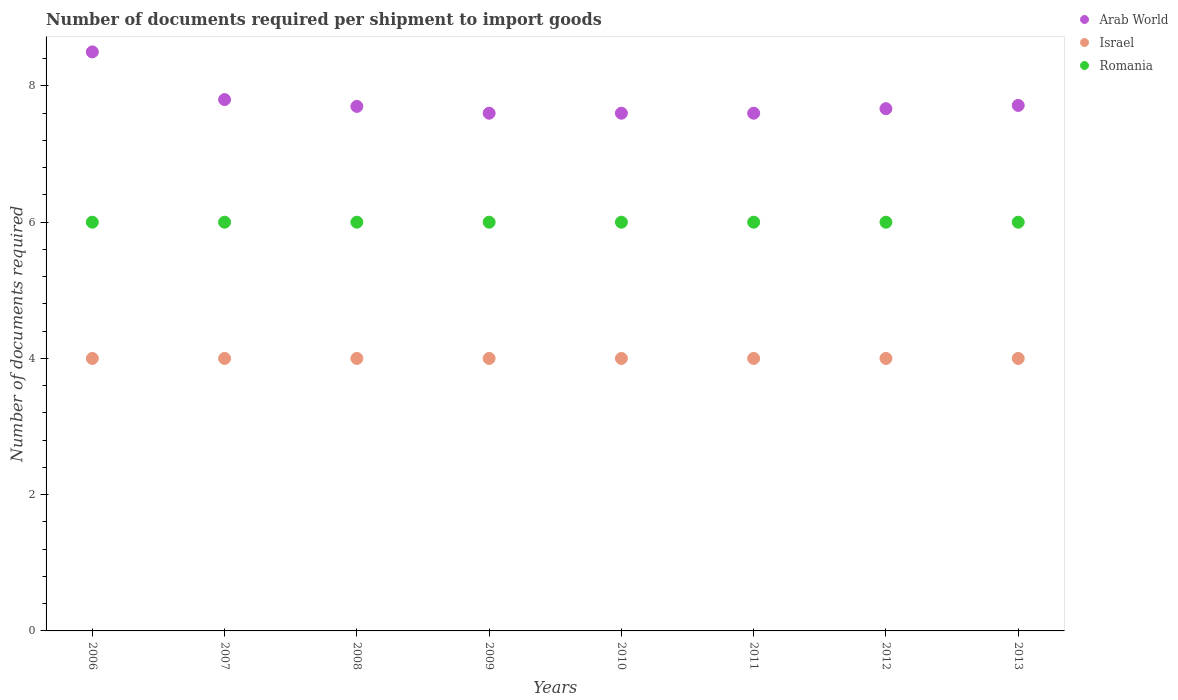Is the number of dotlines equal to the number of legend labels?
Offer a very short reply. Yes. What is the number of documents required per shipment to import goods in Romania in 2006?
Make the answer very short. 6. Across all years, what is the minimum number of documents required per shipment to import goods in Israel?
Your response must be concise. 4. In which year was the number of documents required per shipment to import goods in Israel maximum?
Offer a very short reply. 2006. In which year was the number of documents required per shipment to import goods in Arab World minimum?
Make the answer very short. 2009. What is the total number of documents required per shipment to import goods in Israel in the graph?
Provide a succinct answer. 32. What is the difference between the number of documents required per shipment to import goods in Romania in 2010 and the number of documents required per shipment to import goods in Israel in 2008?
Offer a terse response. 2. What is the average number of documents required per shipment to import goods in Romania per year?
Make the answer very short. 6. In the year 2006, what is the difference between the number of documents required per shipment to import goods in Israel and number of documents required per shipment to import goods in Arab World?
Offer a terse response. -4.5. In how many years, is the number of documents required per shipment to import goods in Israel greater than 5.2?
Your answer should be very brief. 0. What is the ratio of the number of documents required per shipment to import goods in Arab World in 2007 to that in 2011?
Your answer should be very brief. 1.03. What is the difference between the highest and the second highest number of documents required per shipment to import goods in Romania?
Give a very brief answer. 0. In how many years, is the number of documents required per shipment to import goods in Israel greater than the average number of documents required per shipment to import goods in Israel taken over all years?
Provide a short and direct response. 0. Is the sum of the number of documents required per shipment to import goods in Romania in 2009 and 2011 greater than the maximum number of documents required per shipment to import goods in Arab World across all years?
Make the answer very short. Yes. Does the number of documents required per shipment to import goods in Israel monotonically increase over the years?
Your answer should be very brief. No. How many years are there in the graph?
Keep it short and to the point. 8. Does the graph contain any zero values?
Offer a very short reply. No. Does the graph contain grids?
Your answer should be compact. No. Where does the legend appear in the graph?
Offer a terse response. Top right. How many legend labels are there?
Offer a terse response. 3. What is the title of the graph?
Your response must be concise. Number of documents required per shipment to import goods. What is the label or title of the Y-axis?
Make the answer very short. Number of documents required. What is the Number of documents required of Arab World in 2006?
Make the answer very short. 8.5. What is the Number of documents required in Romania in 2006?
Provide a succinct answer. 6. What is the Number of documents required in Arab World in 2007?
Provide a succinct answer. 7.8. What is the Number of documents required of Israel in 2007?
Ensure brevity in your answer.  4. What is the Number of documents required of Arab World in 2008?
Offer a very short reply. 7.7. What is the Number of documents required of Romania in 2008?
Provide a succinct answer. 6. What is the Number of documents required of Israel in 2009?
Ensure brevity in your answer.  4. What is the Number of documents required in Romania in 2009?
Your response must be concise. 6. What is the Number of documents required of Israel in 2011?
Offer a terse response. 4. What is the Number of documents required of Arab World in 2012?
Offer a terse response. 7.67. What is the Number of documents required of Israel in 2012?
Keep it short and to the point. 4. What is the Number of documents required of Arab World in 2013?
Give a very brief answer. 7.71. Across all years, what is the maximum Number of documents required in Arab World?
Your response must be concise. 8.5. Across all years, what is the minimum Number of documents required in Israel?
Provide a succinct answer. 4. Across all years, what is the minimum Number of documents required in Romania?
Offer a very short reply. 6. What is the total Number of documents required of Arab World in the graph?
Offer a terse response. 62.18. What is the total Number of documents required of Romania in the graph?
Provide a short and direct response. 48. What is the difference between the Number of documents required of Romania in 2006 and that in 2007?
Your answer should be compact. 0. What is the difference between the Number of documents required in Romania in 2006 and that in 2008?
Your answer should be compact. 0. What is the difference between the Number of documents required of Israel in 2006 and that in 2009?
Your response must be concise. 0. What is the difference between the Number of documents required in Romania in 2006 and that in 2009?
Your answer should be compact. 0. What is the difference between the Number of documents required in Arab World in 2006 and that in 2010?
Give a very brief answer. 0.9. What is the difference between the Number of documents required in Israel in 2006 and that in 2010?
Provide a short and direct response. 0. What is the difference between the Number of documents required in Israel in 2006 and that in 2011?
Provide a succinct answer. 0. What is the difference between the Number of documents required in Arab World in 2006 and that in 2012?
Make the answer very short. 0.83. What is the difference between the Number of documents required in Romania in 2006 and that in 2012?
Give a very brief answer. 0. What is the difference between the Number of documents required of Arab World in 2006 and that in 2013?
Your answer should be very brief. 0.79. What is the difference between the Number of documents required in Romania in 2006 and that in 2013?
Make the answer very short. 0. What is the difference between the Number of documents required in Arab World in 2007 and that in 2008?
Your answer should be compact. 0.1. What is the difference between the Number of documents required in Israel in 2007 and that in 2009?
Ensure brevity in your answer.  0. What is the difference between the Number of documents required of Israel in 2007 and that in 2010?
Your response must be concise. 0. What is the difference between the Number of documents required in Arab World in 2007 and that in 2011?
Your answer should be compact. 0.2. What is the difference between the Number of documents required of Israel in 2007 and that in 2011?
Offer a very short reply. 0. What is the difference between the Number of documents required in Arab World in 2007 and that in 2012?
Your answer should be very brief. 0.13. What is the difference between the Number of documents required of Romania in 2007 and that in 2012?
Offer a very short reply. 0. What is the difference between the Number of documents required in Arab World in 2007 and that in 2013?
Your response must be concise. 0.09. What is the difference between the Number of documents required of Romania in 2007 and that in 2013?
Offer a very short reply. 0. What is the difference between the Number of documents required of Arab World in 2008 and that in 2009?
Your answer should be compact. 0.1. What is the difference between the Number of documents required of Israel in 2008 and that in 2010?
Keep it short and to the point. 0. What is the difference between the Number of documents required of Romania in 2008 and that in 2010?
Your answer should be compact. 0. What is the difference between the Number of documents required of Israel in 2008 and that in 2011?
Provide a short and direct response. 0. What is the difference between the Number of documents required in Romania in 2008 and that in 2011?
Ensure brevity in your answer.  0. What is the difference between the Number of documents required of Arab World in 2008 and that in 2012?
Offer a terse response. 0.03. What is the difference between the Number of documents required in Israel in 2008 and that in 2012?
Offer a terse response. 0. What is the difference between the Number of documents required of Romania in 2008 and that in 2012?
Offer a very short reply. 0. What is the difference between the Number of documents required of Arab World in 2008 and that in 2013?
Keep it short and to the point. -0.01. What is the difference between the Number of documents required of Israel in 2008 and that in 2013?
Ensure brevity in your answer.  0. What is the difference between the Number of documents required of Arab World in 2009 and that in 2011?
Your response must be concise. 0. What is the difference between the Number of documents required in Romania in 2009 and that in 2011?
Make the answer very short. 0. What is the difference between the Number of documents required in Arab World in 2009 and that in 2012?
Your response must be concise. -0.07. What is the difference between the Number of documents required of Romania in 2009 and that in 2012?
Offer a terse response. 0. What is the difference between the Number of documents required in Arab World in 2009 and that in 2013?
Give a very brief answer. -0.11. What is the difference between the Number of documents required of Romania in 2009 and that in 2013?
Give a very brief answer. 0. What is the difference between the Number of documents required in Romania in 2010 and that in 2011?
Ensure brevity in your answer.  0. What is the difference between the Number of documents required in Arab World in 2010 and that in 2012?
Offer a very short reply. -0.07. What is the difference between the Number of documents required of Arab World in 2010 and that in 2013?
Provide a succinct answer. -0.11. What is the difference between the Number of documents required in Israel in 2010 and that in 2013?
Keep it short and to the point. 0. What is the difference between the Number of documents required in Romania in 2010 and that in 2013?
Ensure brevity in your answer.  0. What is the difference between the Number of documents required of Arab World in 2011 and that in 2012?
Ensure brevity in your answer.  -0.07. What is the difference between the Number of documents required in Arab World in 2011 and that in 2013?
Keep it short and to the point. -0.11. What is the difference between the Number of documents required in Romania in 2011 and that in 2013?
Your answer should be very brief. 0. What is the difference between the Number of documents required in Arab World in 2012 and that in 2013?
Give a very brief answer. -0.05. What is the difference between the Number of documents required in Romania in 2012 and that in 2013?
Offer a terse response. 0. What is the difference between the Number of documents required in Arab World in 2006 and the Number of documents required in Israel in 2007?
Your response must be concise. 4.5. What is the difference between the Number of documents required of Arab World in 2006 and the Number of documents required of Romania in 2007?
Make the answer very short. 2.5. What is the difference between the Number of documents required of Arab World in 2006 and the Number of documents required of Israel in 2008?
Make the answer very short. 4.5. What is the difference between the Number of documents required of Arab World in 2006 and the Number of documents required of Israel in 2010?
Your answer should be very brief. 4.5. What is the difference between the Number of documents required of Arab World in 2006 and the Number of documents required of Romania in 2010?
Provide a short and direct response. 2.5. What is the difference between the Number of documents required of Arab World in 2006 and the Number of documents required of Israel in 2011?
Your response must be concise. 4.5. What is the difference between the Number of documents required in Israel in 2006 and the Number of documents required in Romania in 2011?
Your answer should be very brief. -2. What is the difference between the Number of documents required of Arab World in 2006 and the Number of documents required of Israel in 2012?
Offer a terse response. 4.5. What is the difference between the Number of documents required in Arab World in 2006 and the Number of documents required in Romania in 2012?
Keep it short and to the point. 2.5. What is the difference between the Number of documents required in Arab World in 2006 and the Number of documents required in Romania in 2013?
Your answer should be very brief. 2.5. What is the difference between the Number of documents required of Israel in 2006 and the Number of documents required of Romania in 2013?
Offer a very short reply. -2. What is the difference between the Number of documents required of Arab World in 2007 and the Number of documents required of Israel in 2008?
Provide a short and direct response. 3.8. What is the difference between the Number of documents required in Israel in 2007 and the Number of documents required in Romania in 2009?
Ensure brevity in your answer.  -2. What is the difference between the Number of documents required of Arab World in 2007 and the Number of documents required of Romania in 2010?
Provide a succinct answer. 1.8. What is the difference between the Number of documents required of Israel in 2007 and the Number of documents required of Romania in 2010?
Your response must be concise. -2. What is the difference between the Number of documents required in Arab World in 2007 and the Number of documents required in Israel in 2011?
Offer a very short reply. 3.8. What is the difference between the Number of documents required of Israel in 2007 and the Number of documents required of Romania in 2011?
Offer a terse response. -2. What is the difference between the Number of documents required of Arab World in 2007 and the Number of documents required of Romania in 2012?
Provide a succinct answer. 1.8. What is the difference between the Number of documents required of Israel in 2007 and the Number of documents required of Romania in 2013?
Provide a succinct answer. -2. What is the difference between the Number of documents required of Arab World in 2008 and the Number of documents required of Israel in 2009?
Keep it short and to the point. 3.7. What is the difference between the Number of documents required in Arab World in 2008 and the Number of documents required in Romania in 2009?
Make the answer very short. 1.7. What is the difference between the Number of documents required in Arab World in 2008 and the Number of documents required in Romania in 2010?
Your answer should be very brief. 1.7. What is the difference between the Number of documents required in Arab World in 2008 and the Number of documents required in Israel in 2011?
Provide a short and direct response. 3.7. What is the difference between the Number of documents required of Israel in 2008 and the Number of documents required of Romania in 2011?
Give a very brief answer. -2. What is the difference between the Number of documents required of Arab World in 2008 and the Number of documents required of Israel in 2012?
Your response must be concise. 3.7. What is the difference between the Number of documents required in Arab World in 2008 and the Number of documents required in Romania in 2012?
Provide a short and direct response. 1.7. What is the difference between the Number of documents required of Israel in 2008 and the Number of documents required of Romania in 2012?
Offer a terse response. -2. What is the difference between the Number of documents required in Arab World in 2008 and the Number of documents required in Israel in 2013?
Give a very brief answer. 3.7. What is the difference between the Number of documents required in Arab World in 2009 and the Number of documents required in Israel in 2010?
Ensure brevity in your answer.  3.6. What is the difference between the Number of documents required in Arab World in 2009 and the Number of documents required in Romania in 2010?
Your response must be concise. 1.6. What is the difference between the Number of documents required of Israel in 2009 and the Number of documents required of Romania in 2010?
Keep it short and to the point. -2. What is the difference between the Number of documents required in Israel in 2009 and the Number of documents required in Romania in 2011?
Keep it short and to the point. -2. What is the difference between the Number of documents required in Arab World in 2009 and the Number of documents required in Israel in 2012?
Offer a very short reply. 3.6. What is the difference between the Number of documents required of Arab World in 2009 and the Number of documents required of Romania in 2012?
Provide a short and direct response. 1.6. What is the difference between the Number of documents required of Israel in 2009 and the Number of documents required of Romania in 2012?
Provide a short and direct response. -2. What is the difference between the Number of documents required in Arab World in 2010 and the Number of documents required in Israel in 2011?
Provide a succinct answer. 3.6. What is the difference between the Number of documents required of Israel in 2010 and the Number of documents required of Romania in 2011?
Keep it short and to the point. -2. What is the difference between the Number of documents required in Arab World in 2010 and the Number of documents required in Israel in 2012?
Make the answer very short. 3.6. What is the difference between the Number of documents required of Israel in 2010 and the Number of documents required of Romania in 2012?
Your answer should be compact. -2. What is the difference between the Number of documents required of Arab World in 2010 and the Number of documents required of Romania in 2013?
Make the answer very short. 1.6. What is the difference between the Number of documents required in Israel in 2010 and the Number of documents required in Romania in 2013?
Provide a succinct answer. -2. What is the difference between the Number of documents required of Arab World in 2011 and the Number of documents required of Israel in 2013?
Make the answer very short. 3.6. What is the difference between the Number of documents required of Israel in 2011 and the Number of documents required of Romania in 2013?
Offer a very short reply. -2. What is the difference between the Number of documents required in Arab World in 2012 and the Number of documents required in Israel in 2013?
Ensure brevity in your answer.  3.67. What is the difference between the Number of documents required in Arab World in 2012 and the Number of documents required in Romania in 2013?
Make the answer very short. 1.67. What is the difference between the Number of documents required of Israel in 2012 and the Number of documents required of Romania in 2013?
Keep it short and to the point. -2. What is the average Number of documents required in Arab World per year?
Your response must be concise. 7.77. What is the average Number of documents required of Israel per year?
Your answer should be very brief. 4. In the year 2006, what is the difference between the Number of documents required in Arab World and Number of documents required in Israel?
Your response must be concise. 4.5. In the year 2006, what is the difference between the Number of documents required in Arab World and Number of documents required in Romania?
Your answer should be compact. 2.5. In the year 2006, what is the difference between the Number of documents required in Israel and Number of documents required in Romania?
Offer a terse response. -2. In the year 2007, what is the difference between the Number of documents required in Arab World and Number of documents required in Israel?
Your response must be concise. 3.8. In the year 2007, what is the difference between the Number of documents required in Arab World and Number of documents required in Romania?
Keep it short and to the point. 1.8. In the year 2008, what is the difference between the Number of documents required of Arab World and Number of documents required of Israel?
Provide a short and direct response. 3.7. In the year 2008, what is the difference between the Number of documents required of Arab World and Number of documents required of Romania?
Keep it short and to the point. 1.7. In the year 2008, what is the difference between the Number of documents required of Israel and Number of documents required of Romania?
Make the answer very short. -2. In the year 2009, what is the difference between the Number of documents required of Arab World and Number of documents required of Israel?
Your response must be concise. 3.6. In the year 2010, what is the difference between the Number of documents required of Israel and Number of documents required of Romania?
Offer a terse response. -2. In the year 2011, what is the difference between the Number of documents required in Arab World and Number of documents required in Israel?
Give a very brief answer. 3.6. In the year 2011, what is the difference between the Number of documents required of Arab World and Number of documents required of Romania?
Make the answer very short. 1.6. In the year 2012, what is the difference between the Number of documents required in Arab World and Number of documents required in Israel?
Offer a very short reply. 3.67. In the year 2012, what is the difference between the Number of documents required in Arab World and Number of documents required in Romania?
Provide a succinct answer. 1.67. In the year 2012, what is the difference between the Number of documents required of Israel and Number of documents required of Romania?
Keep it short and to the point. -2. In the year 2013, what is the difference between the Number of documents required in Arab World and Number of documents required in Israel?
Provide a short and direct response. 3.71. In the year 2013, what is the difference between the Number of documents required of Arab World and Number of documents required of Romania?
Provide a succinct answer. 1.71. In the year 2013, what is the difference between the Number of documents required in Israel and Number of documents required in Romania?
Make the answer very short. -2. What is the ratio of the Number of documents required in Arab World in 2006 to that in 2007?
Ensure brevity in your answer.  1.09. What is the ratio of the Number of documents required of Israel in 2006 to that in 2007?
Your answer should be compact. 1. What is the ratio of the Number of documents required of Arab World in 2006 to that in 2008?
Provide a short and direct response. 1.1. What is the ratio of the Number of documents required in Arab World in 2006 to that in 2009?
Your answer should be very brief. 1.12. What is the ratio of the Number of documents required of Israel in 2006 to that in 2009?
Your answer should be compact. 1. What is the ratio of the Number of documents required in Romania in 2006 to that in 2009?
Your answer should be very brief. 1. What is the ratio of the Number of documents required in Arab World in 2006 to that in 2010?
Offer a terse response. 1.12. What is the ratio of the Number of documents required in Israel in 2006 to that in 2010?
Offer a very short reply. 1. What is the ratio of the Number of documents required in Romania in 2006 to that in 2010?
Keep it short and to the point. 1. What is the ratio of the Number of documents required in Arab World in 2006 to that in 2011?
Provide a succinct answer. 1.12. What is the ratio of the Number of documents required in Israel in 2006 to that in 2011?
Make the answer very short. 1. What is the ratio of the Number of documents required in Romania in 2006 to that in 2011?
Provide a succinct answer. 1. What is the ratio of the Number of documents required in Arab World in 2006 to that in 2012?
Make the answer very short. 1.11. What is the ratio of the Number of documents required in Israel in 2006 to that in 2012?
Make the answer very short. 1. What is the ratio of the Number of documents required of Arab World in 2006 to that in 2013?
Keep it short and to the point. 1.1. What is the ratio of the Number of documents required in Romania in 2006 to that in 2013?
Offer a terse response. 1. What is the ratio of the Number of documents required in Arab World in 2007 to that in 2009?
Your response must be concise. 1.03. What is the ratio of the Number of documents required in Arab World in 2007 to that in 2010?
Provide a succinct answer. 1.03. What is the ratio of the Number of documents required of Israel in 2007 to that in 2010?
Provide a succinct answer. 1. What is the ratio of the Number of documents required of Arab World in 2007 to that in 2011?
Offer a very short reply. 1.03. What is the ratio of the Number of documents required in Romania in 2007 to that in 2011?
Offer a terse response. 1. What is the ratio of the Number of documents required of Arab World in 2007 to that in 2012?
Make the answer very short. 1.02. What is the ratio of the Number of documents required of Arab World in 2007 to that in 2013?
Provide a short and direct response. 1.01. What is the ratio of the Number of documents required in Israel in 2007 to that in 2013?
Keep it short and to the point. 1. What is the ratio of the Number of documents required of Romania in 2007 to that in 2013?
Keep it short and to the point. 1. What is the ratio of the Number of documents required in Arab World in 2008 to that in 2009?
Your answer should be very brief. 1.01. What is the ratio of the Number of documents required in Israel in 2008 to that in 2009?
Keep it short and to the point. 1. What is the ratio of the Number of documents required in Romania in 2008 to that in 2009?
Give a very brief answer. 1. What is the ratio of the Number of documents required in Arab World in 2008 to that in 2010?
Give a very brief answer. 1.01. What is the ratio of the Number of documents required in Israel in 2008 to that in 2010?
Keep it short and to the point. 1. What is the ratio of the Number of documents required of Romania in 2008 to that in 2010?
Make the answer very short. 1. What is the ratio of the Number of documents required of Arab World in 2008 to that in 2011?
Provide a succinct answer. 1.01. What is the ratio of the Number of documents required of Romania in 2008 to that in 2011?
Offer a terse response. 1. What is the ratio of the Number of documents required of Israel in 2008 to that in 2012?
Provide a succinct answer. 1. What is the ratio of the Number of documents required of Romania in 2008 to that in 2013?
Offer a very short reply. 1. What is the ratio of the Number of documents required of Israel in 2009 to that in 2010?
Your answer should be compact. 1. What is the ratio of the Number of documents required in Romania in 2009 to that in 2010?
Your answer should be very brief. 1. What is the ratio of the Number of documents required of Arab World in 2009 to that in 2011?
Keep it short and to the point. 1. What is the ratio of the Number of documents required in Israel in 2009 to that in 2012?
Keep it short and to the point. 1. What is the ratio of the Number of documents required of Romania in 2009 to that in 2012?
Keep it short and to the point. 1. What is the ratio of the Number of documents required in Arab World in 2009 to that in 2013?
Give a very brief answer. 0.99. What is the ratio of the Number of documents required of Romania in 2009 to that in 2013?
Your answer should be very brief. 1. What is the ratio of the Number of documents required in Israel in 2010 to that in 2011?
Ensure brevity in your answer.  1. What is the ratio of the Number of documents required in Arab World in 2010 to that in 2013?
Ensure brevity in your answer.  0.99. What is the ratio of the Number of documents required in Israel in 2010 to that in 2013?
Your answer should be very brief. 1. What is the ratio of the Number of documents required of Romania in 2011 to that in 2012?
Provide a succinct answer. 1. What is the ratio of the Number of documents required of Arab World in 2011 to that in 2013?
Your answer should be compact. 0.99. What is the ratio of the Number of documents required of Romania in 2012 to that in 2013?
Your response must be concise. 1. 